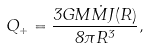Convert formula to latex. <formula><loc_0><loc_0><loc_500><loc_500>Q _ { + } = \frac { 3 G M \dot { M } J ( R ) } { 8 \pi R ^ { 3 } } ,</formula> 